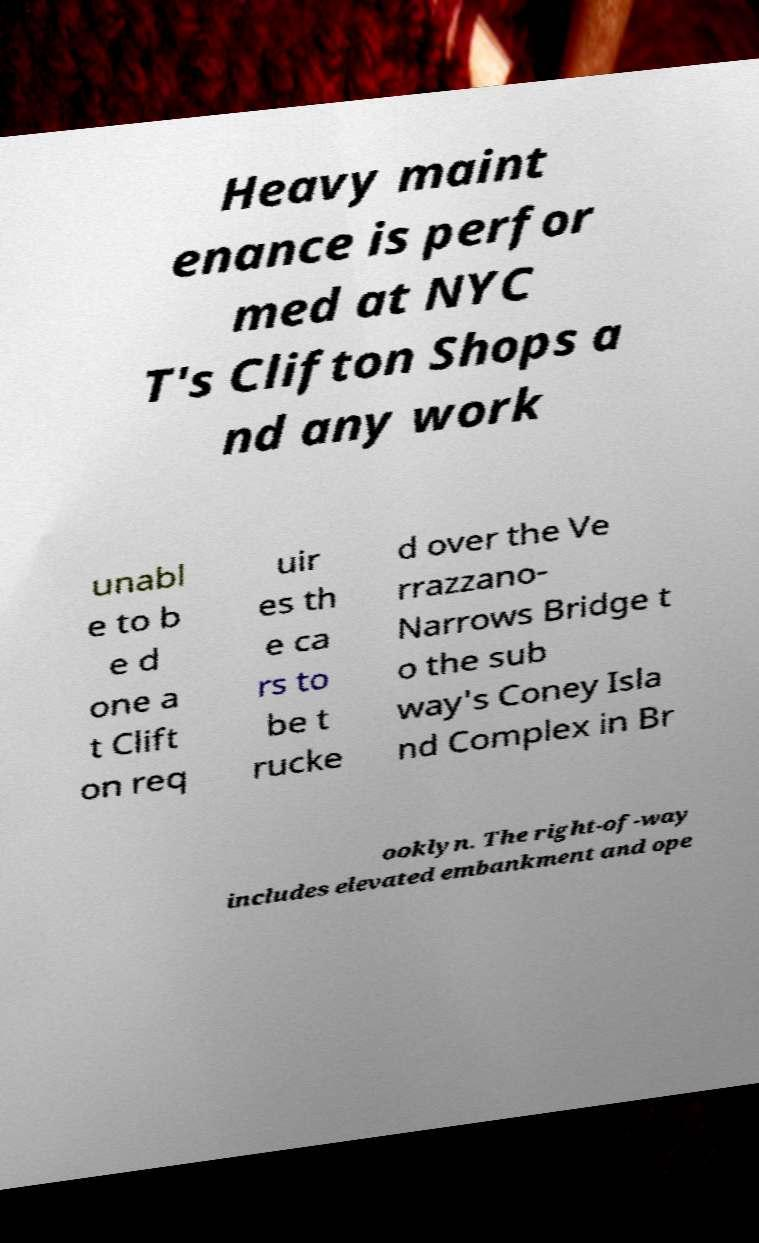I need the written content from this picture converted into text. Can you do that? Heavy maint enance is perfor med at NYC T's Clifton Shops a nd any work unabl e to b e d one a t Clift on req uir es th e ca rs to be t rucke d over the Ve rrazzano- Narrows Bridge t o the sub way's Coney Isla nd Complex in Br ooklyn. The right-of-way includes elevated embankment and ope 